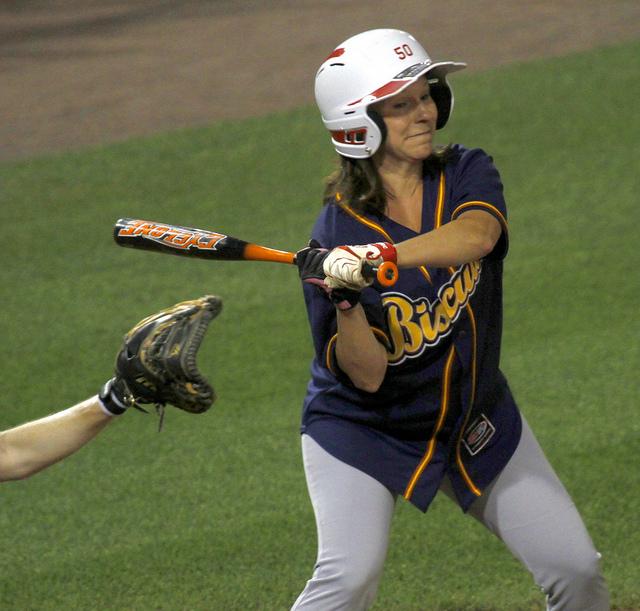What color is his batting helmet?
Short answer required. White. What color is the bat?
Give a very brief answer. Black and orange. Is the woman a professional player?
Concise answer only. No. What sport is the woman playing?
Be succinct. Baseball. 